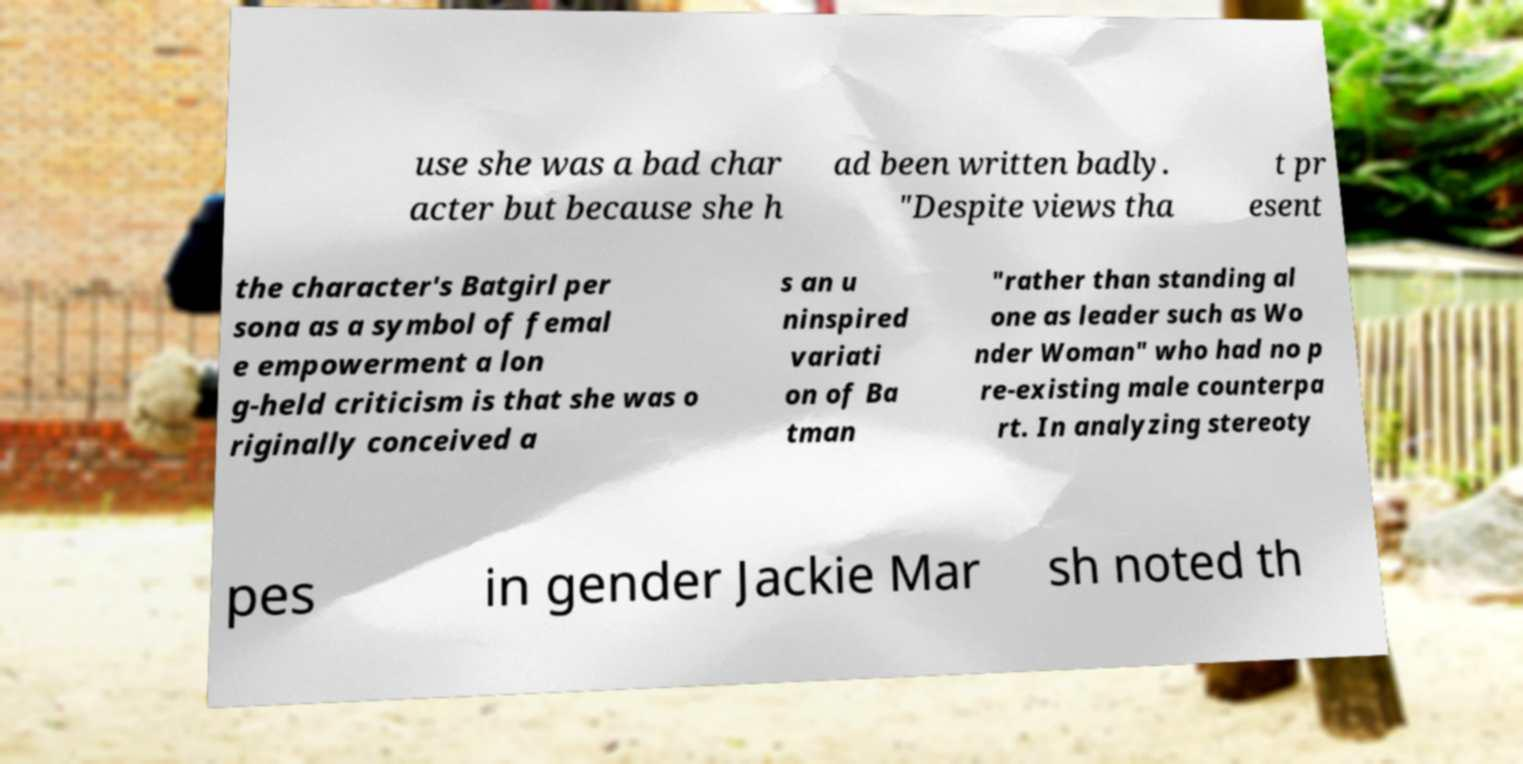There's text embedded in this image that I need extracted. Can you transcribe it verbatim? use she was a bad char acter but because she h ad been written badly. "Despite views tha t pr esent the character's Batgirl per sona as a symbol of femal e empowerment a lon g-held criticism is that she was o riginally conceived a s an u ninspired variati on of Ba tman "rather than standing al one as leader such as Wo nder Woman" who had no p re-existing male counterpa rt. In analyzing stereoty pes in gender Jackie Mar sh noted th 